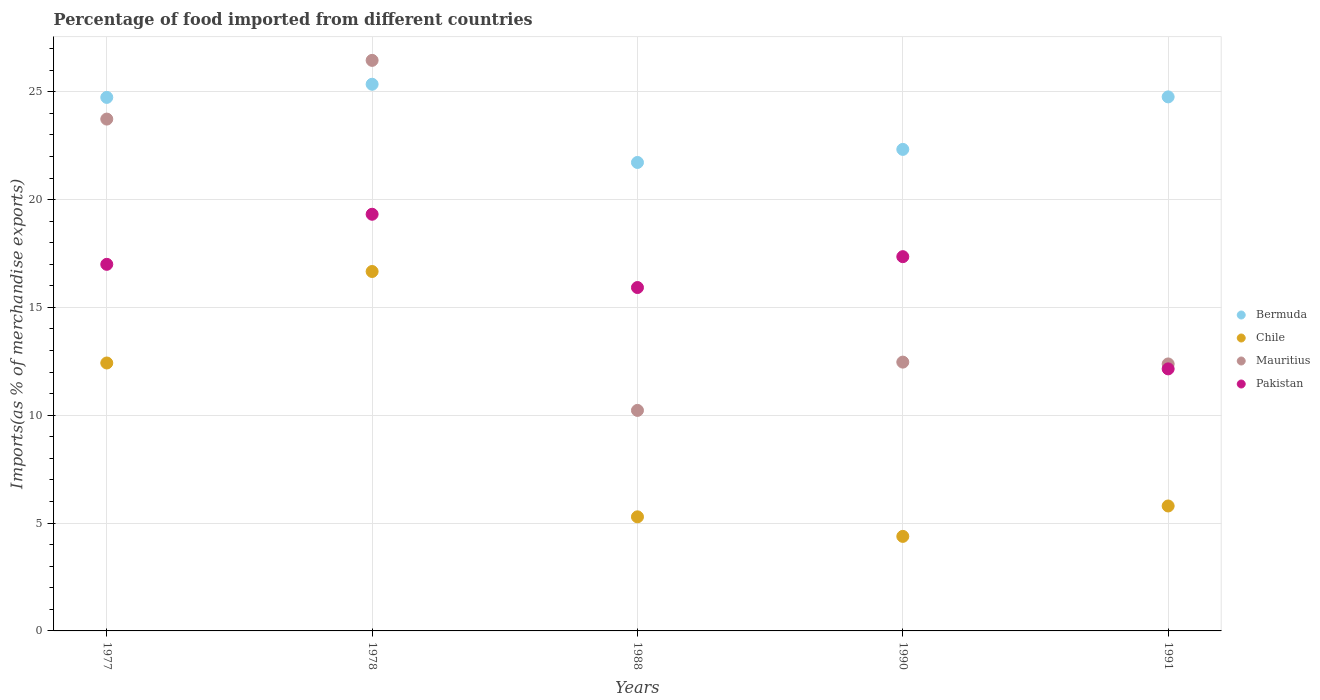Is the number of dotlines equal to the number of legend labels?
Make the answer very short. Yes. What is the percentage of imports to different countries in Mauritius in 1991?
Offer a very short reply. 12.38. Across all years, what is the maximum percentage of imports to different countries in Chile?
Provide a succinct answer. 16.67. Across all years, what is the minimum percentage of imports to different countries in Pakistan?
Your response must be concise. 12.15. In which year was the percentage of imports to different countries in Bermuda maximum?
Offer a terse response. 1978. What is the total percentage of imports to different countries in Chile in the graph?
Give a very brief answer. 44.55. What is the difference between the percentage of imports to different countries in Bermuda in 1978 and that in 1990?
Keep it short and to the point. 3.02. What is the difference between the percentage of imports to different countries in Pakistan in 1988 and the percentage of imports to different countries in Chile in 1977?
Make the answer very short. 3.5. What is the average percentage of imports to different countries in Chile per year?
Your answer should be compact. 8.91. In the year 1990, what is the difference between the percentage of imports to different countries in Bermuda and percentage of imports to different countries in Chile?
Provide a short and direct response. 17.94. In how many years, is the percentage of imports to different countries in Bermuda greater than 11 %?
Provide a short and direct response. 5. What is the ratio of the percentage of imports to different countries in Bermuda in 1978 to that in 1988?
Ensure brevity in your answer.  1.17. What is the difference between the highest and the second highest percentage of imports to different countries in Chile?
Your answer should be very brief. 4.24. What is the difference between the highest and the lowest percentage of imports to different countries in Bermuda?
Your answer should be compact. 3.63. In how many years, is the percentage of imports to different countries in Bermuda greater than the average percentage of imports to different countries in Bermuda taken over all years?
Keep it short and to the point. 3. Is the percentage of imports to different countries in Bermuda strictly less than the percentage of imports to different countries in Chile over the years?
Offer a very short reply. No. How many dotlines are there?
Provide a succinct answer. 4. How many years are there in the graph?
Your answer should be very brief. 5. Are the values on the major ticks of Y-axis written in scientific E-notation?
Keep it short and to the point. No. Does the graph contain any zero values?
Provide a succinct answer. No. How many legend labels are there?
Your answer should be very brief. 4. What is the title of the graph?
Make the answer very short. Percentage of food imported from different countries. What is the label or title of the Y-axis?
Ensure brevity in your answer.  Imports(as % of merchandise exports). What is the Imports(as % of merchandise exports) in Bermuda in 1977?
Provide a succinct answer. 24.74. What is the Imports(as % of merchandise exports) in Chile in 1977?
Provide a short and direct response. 12.42. What is the Imports(as % of merchandise exports) of Mauritius in 1977?
Provide a succinct answer. 23.73. What is the Imports(as % of merchandise exports) of Pakistan in 1977?
Your answer should be very brief. 17. What is the Imports(as % of merchandise exports) of Bermuda in 1978?
Ensure brevity in your answer.  25.35. What is the Imports(as % of merchandise exports) in Chile in 1978?
Provide a short and direct response. 16.67. What is the Imports(as % of merchandise exports) of Mauritius in 1978?
Provide a short and direct response. 26.45. What is the Imports(as % of merchandise exports) of Pakistan in 1978?
Your answer should be compact. 19.32. What is the Imports(as % of merchandise exports) of Bermuda in 1988?
Your response must be concise. 21.72. What is the Imports(as % of merchandise exports) in Chile in 1988?
Your answer should be very brief. 5.29. What is the Imports(as % of merchandise exports) in Mauritius in 1988?
Ensure brevity in your answer.  10.22. What is the Imports(as % of merchandise exports) in Pakistan in 1988?
Your response must be concise. 15.92. What is the Imports(as % of merchandise exports) in Bermuda in 1990?
Keep it short and to the point. 22.33. What is the Imports(as % of merchandise exports) in Chile in 1990?
Your response must be concise. 4.38. What is the Imports(as % of merchandise exports) of Mauritius in 1990?
Your response must be concise. 12.46. What is the Imports(as % of merchandise exports) of Pakistan in 1990?
Offer a very short reply. 17.35. What is the Imports(as % of merchandise exports) in Bermuda in 1991?
Your answer should be very brief. 24.76. What is the Imports(as % of merchandise exports) in Chile in 1991?
Ensure brevity in your answer.  5.79. What is the Imports(as % of merchandise exports) in Mauritius in 1991?
Make the answer very short. 12.38. What is the Imports(as % of merchandise exports) in Pakistan in 1991?
Your response must be concise. 12.15. Across all years, what is the maximum Imports(as % of merchandise exports) of Bermuda?
Offer a very short reply. 25.35. Across all years, what is the maximum Imports(as % of merchandise exports) in Chile?
Your response must be concise. 16.67. Across all years, what is the maximum Imports(as % of merchandise exports) of Mauritius?
Your answer should be compact. 26.45. Across all years, what is the maximum Imports(as % of merchandise exports) of Pakistan?
Make the answer very short. 19.32. Across all years, what is the minimum Imports(as % of merchandise exports) of Bermuda?
Ensure brevity in your answer.  21.72. Across all years, what is the minimum Imports(as % of merchandise exports) in Chile?
Provide a short and direct response. 4.38. Across all years, what is the minimum Imports(as % of merchandise exports) in Mauritius?
Your answer should be very brief. 10.22. Across all years, what is the minimum Imports(as % of merchandise exports) in Pakistan?
Keep it short and to the point. 12.15. What is the total Imports(as % of merchandise exports) in Bermuda in the graph?
Offer a terse response. 118.89. What is the total Imports(as % of merchandise exports) in Chile in the graph?
Keep it short and to the point. 44.55. What is the total Imports(as % of merchandise exports) of Mauritius in the graph?
Your answer should be compact. 85.25. What is the total Imports(as % of merchandise exports) of Pakistan in the graph?
Ensure brevity in your answer.  81.74. What is the difference between the Imports(as % of merchandise exports) of Bermuda in 1977 and that in 1978?
Provide a succinct answer. -0.61. What is the difference between the Imports(as % of merchandise exports) of Chile in 1977 and that in 1978?
Provide a succinct answer. -4.24. What is the difference between the Imports(as % of merchandise exports) of Mauritius in 1977 and that in 1978?
Offer a terse response. -2.72. What is the difference between the Imports(as % of merchandise exports) in Pakistan in 1977 and that in 1978?
Your answer should be very brief. -2.32. What is the difference between the Imports(as % of merchandise exports) in Bermuda in 1977 and that in 1988?
Provide a succinct answer. 3.02. What is the difference between the Imports(as % of merchandise exports) in Chile in 1977 and that in 1988?
Your response must be concise. 7.13. What is the difference between the Imports(as % of merchandise exports) of Mauritius in 1977 and that in 1988?
Offer a very short reply. 13.51. What is the difference between the Imports(as % of merchandise exports) in Pakistan in 1977 and that in 1988?
Provide a succinct answer. 1.08. What is the difference between the Imports(as % of merchandise exports) in Bermuda in 1977 and that in 1990?
Give a very brief answer. 2.41. What is the difference between the Imports(as % of merchandise exports) of Chile in 1977 and that in 1990?
Keep it short and to the point. 8.04. What is the difference between the Imports(as % of merchandise exports) in Mauritius in 1977 and that in 1990?
Give a very brief answer. 11.27. What is the difference between the Imports(as % of merchandise exports) in Pakistan in 1977 and that in 1990?
Ensure brevity in your answer.  -0.36. What is the difference between the Imports(as % of merchandise exports) in Bermuda in 1977 and that in 1991?
Your answer should be very brief. -0.02. What is the difference between the Imports(as % of merchandise exports) of Chile in 1977 and that in 1991?
Your response must be concise. 6.63. What is the difference between the Imports(as % of merchandise exports) of Mauritius in 1977 and that in 1991?
Offer a very short reply. 11.35. What is the difference between the Imports(as % of merchandise exports) of Pakistan in 1977 and that in 1991?
Ensure brevity in your answer.  4.85. What is the difference between the Imports(as % of merchandise exports) in Bermuda in 1978 and that in 1988?
Ensure brevity in your answer.  3.63. What is the difference between the Imports(as % of merchandise exports) in Chile in 1978 and that in 1988?
Keep it short and to the point. 11.38. What is the difference between the Imports(as % of merchandise exports) of Mauritius in 1978 and that in 1988?
Offer a terse response. 16.23. What is the difference between the Imports(as % of merchandise exports) of Pakistan in 1978 and that in 1988?
Keep it short and to the point. 3.4. What is the difference between the Imports(as % of merchandise exports) in Bermuda in 1978 and that in 1990?
Your response must be concise. 3.02. What is the difference between the Imports(as % of merchandise exports) of Chile in 1978 and that in 1990?
Offer a very short reply. 12.28. What is the difference between the Imports(as % of merchandise exports) of Mauritius in 1978 and that in 1990?
Your answer should be compact. 13.99. What is the difference between the Imports(as % of merchandise exports) in Pakistan in 1978 and that in 1990?
Give a very brief answer. 1.97. What is the difference between the Imports(as % of merchandise exports) of Bermuda in 1978 and that in 1991?
Your answer should be very brief. 0.59. What is the difference between the Imports(as % of merchandise exports) in Chile in 1978 and that in 1991?
Provide a short and direct response. 10.87. What is the difference between the Imports(as % of merchandise exports) of Mauritius in 1978 and that in 1991?
Give a very brief answer. 14.08. What is the difference between the Imports(as % of merchandise exports) of Pakistan in 1978 and that in 1991?
Offer a very short reply. 7.17. What is the difference between the Imports(as % of merchandise exports) of Bermuda in 1988 and that in 1990?
Provide a short and direct response. -0.61. What is the difference between the Imports(as % of merchandise exports) in Chile in 1988 and that in 1990?
Keep it short and to the point. 0.91. What is the difference between the Imports(as % of merchandise exports) in Mauritius in 1988 and that in 1990?
Your answer should be compact. -2.24. What is the difference between the Imports(as % of merchandise exports) in Pakistan in 1988 and that in 1990?
Offer a very short reply. -1.43. What is the difference between the Imports(as % of merchandise exports) in Bermuda in 1988 and that in 1991?
Your response must be concise. -3.04. What is the difference between the Imports(as % of merchandise exports) of Chile in 1988 and that in 1991?
Ensure brevity in your answer.  -0.5. What is the difference between the Imports(as % of merchandise exports) in Mauritius in 1988 and that in 1991?
Make the answer very short. -2.15. What is the difference between the Imports(as % of merchandise exports) of Pakistan in 1988 and that in 1991?
Keep it short and to the point. 3.77. What is the difference between the Imports(as % of merchandise exports) in Bermuda in 1990 and that in 1991?
Your answer should be very brief. -2.43. What is the difference between the Imports(as % of merchandise exports) of Chile in 1990 and that in 1991?
Your response must be concise. -1.41. What is the difference between the Imports(as % of merchandise exports) in Mauritius in 1990 and that in 1991?
Ensure brevity in your answer.  0.08. What is the difference between the Imports(as % of merchandise exports) of Pakistan in 1990 and that in 1991?
Keep it short and to the point. 5.2. What is the difference between the Imports(as % of merchandise exports) of Bermuda in 1977 and the Imports(as % of merchandise exports) of Chile in 1978?
Give a very brief answer. 8.07. What is the difference between the Imports(as % of merchandise exports) of Bermuda in 1977 and the Imports(as % of merchandise exports) of Mauritius in 1978?
Provide a succinct answer. -1.72. What is the difference between the Imports(as % of merchandise exports) in Bermuda in 1977 and the Imports(as % of merchandise exports) in Pakistan in 1978?
Keep it short and to the point. 5.42. What is the difference between the Imports(as % of merchandise exports) in Chile in 1977 and the Imports(as % of merchandise exports) in Mauritius in 1978?
Your answer should be compact. -14.03. What is the difference between the Imports(as % of merchandise exports) in Chile in 1977 and the Imports(as % of merchandise exports) in Pakistan in 1978?
Make the answer very short. -6.9. What is the difference between the Imports(as % of merchandise exports) in Mauritius in 1977 and the Imports(as % of merchandise exports) in Pakistan in 1978?
Your response must be concise. 4.41. What is the difference between the Imports(as % of merchandise exports) in Bermuda in 1977 and the Imports(as % of merchandise exports) in Chile in 1988?
Make the answer very short. 19.45. What is the difference between the Imports(as % of merchandise exports) of Bermuda in 1977 and the Imports(as % of merchandise exports) of Mauritius in 1988?
Make the answer very short. 14.51. What is the difference between the Imports(as % of merchandise exports) of Bermuda in 1977 and the Imports(as % of merchandise exports) of Pakistan in 1988?
Your answer should be compact. 8.82. What is the difference between the Imports(as % of merchandise exports) of Chile in 1977 and the Imports(as % of merchandise exports) of Mauritius in 1988?
Provide a succinct answer. 2.2. What is the difference between the Imports(as % of merchandise exports) of Chile in 1977 and the Imports(as % of merchandise exports) of Pakistan in 1988?
Your response must be concise. -3.5. What is the difference between the Imports(as % of merchandise exports) in Mauritius in 1977 and the Imports(as % of merchandise exports) in Pakistan in 1988?
Keep it short and to the point. 7.81. What is the difference between the Imports(as % of merchandise exports) of Bermuda in 1977 and the Imports(as % of merchandise exports) of Chile in 1990?
Your answer should be very brief. 20.35. What is the difference between the Imports(as % of merchandise exports) of Bermuda in 1977 and the Imports(as % of merchandise exports) of Mauritius in 1990?
Keep it short and to the point. 12.27. What is the difference between the Imports(as % of merchandise exports) of Bermuda in 1977 and the Imports(as % of merchandise exports) of Pakistan in 1990?
Offer a very short reply. 7.38. What is the difference between the Imports(as % of merchandise exports) of Chile in 1977 and the Imports(as % of merchandise exports) of Mauritius in 1990?
Offer a very short reply. -0.04. What is the difference between the Imports(as % of merchandise exports) of Chile in 1977 and the Imports(as % of merchandise exports) of Pakistan in 1990?
Ensure brevity in your answer.  -4.93. What is the difference between the Imports(as % of merchandise exports) in Mauritius in 1977 and the Imports(as % of merchandise exports) in Pakistan in 1990?
Keep it short and to the point. 6.38. What is the difference between the Imports(as % of merchandise exports) in Bermuda in 1977 and the Imports(as % of merchandise exports) in Chile in 1991?
Ensure brevity in your answer.  18.94. What is the difference between the Imports(as % of merchandise exports) of Bermuda in 1977 and the Imports(as % of merchandise exports) of Mauritius in 1991?
Offer a very short reply. 12.36. What is the difference between the Imports(as % of merchandise exports) of Bermuda in 1977 and the Imports(as % of merchandise exports) of Pakistan in 1991?
Your answer should be very brief. 12.59. What is the difference between the Imports(as % of merchandise exports) in Chile in 1977 and the Imports(as % of merchandise exports) in Mauritius in 1991?
Give a very brief answer. 0.04. What is the difference between the Imports(as % of merchandise exports) in Chile in 1977 and the Imports(as % of merchandise exports) in Pakistan in 1991?
Your answer should be compact. 0.27. What is the difference between the Imports(as % of merchandise exports) of Mauritius in 1977 and the Imports(as % of merchandise exports) of Pakistan in 1991?
Your response must be concise. 11.58. What is the difference between the Imports(as % of merchandise exports) in Bermuda in 1978 and the Imports(as % of merchandise exports) in Chile in 1988?
Offer a very short reply. 20.06. What is the difference between the Imports(as % of merchandise exports) in Bermuda in 1978 and the Imports(as % of merchandise exports) in Mauritius in 1988?
Your answer should be very brief. 15.12. What is the difference between the Imports(as % of merchandise exports) in Bermuda in 1978 and the Imports(as % of merchandise exports) in Pakistan in 1988?
Offer a terse response. 9.43. What is the difference between the Imports(as % of merchandise exports) of Chile in 1978 and the Imports(as % of merchandise exports) of Mauritius in 1988?
Your response must be concise. 6.44. What is the difference between the Imports(as % of merchandise exports) of Chile in 1978 and the Imports(as % of merchandise exports) of Pakistan in 1988?
Your answer should be very brief. 0.74. What is the difference between the Imports(as % of merchandise exports) in Mauritius in 1978 and the Imports(as % of merchandise exports) in Pakistan in 1988?
Offer a very short reply. 10.53. What is the difference between the Imports(as % of merchandise exports) in Bermuda in 1978 and the Imports(as % of merchandise exports) in Chile in 1990?
Your answer should be compact. 20.96. What is the difference between the Imports(as % of merchandise exports) in Bermuda in 1978 and the Imports(as % of merchandise exports) in Mauritius in 1990?
Give a very brief answer. 12.88. What is the difference between the Imports(as % of merchandise exports) of Bermuda in 1978 and the Imports(as % of merchandise exports) of Pakistan in 1990?
Provide a short and direct response. 7.99. What is the difference between the Imports(as % of merchandise exports) in Chile in 1978 and the Imports(as % of merchandise exports) in Mauritius in 1990?
Your answer should be compact. 4.2. What is the difference between the Imports(as % of merchandise exports) in Chile in 1978 and the Imports(as % of merchandise exports) in Pakistan in 1990?
Provide a short and direct response. -0.69. What is the difference between the Imports(as % of merchandise exports) in Mauritius in 1978 and the Imports(as % of merchandise exports) in Pakistan in 1990?
Your response must be concise. 9.1. What is the difference between the Imports(as % of merchandise exports) of Bermuda in 1978 and the Imports(as % of merchandise exports) of Chile in 1991?
Your answer should be very brief. 19.55. What is the difference between the Imports(as % of merchandise exports) of Bermuda in 1978 and the Imports(as % of merchandise exports) of Mauritius in 1991?
Offer a terse response. 12.97. What is the difference between the Imports(as % of merchandise exports) in Bermuda in 1978 and the Imports(as % of merchandise exports) in Pakistan in 1991?
Give a very brief answer. 13.2. What is the difference between the Imports(as % of merchandise exports) of Chile in 1978 and the Imports(as % of merchandise exports) of Mauritius in 1991?
Your response must be concise. 4.29. What is the difference between the Imports(as % of merchandise exports) in Chile in 1978 and the Imports(as % of merchandise exports) in Pakistan in 1991?
Provide a succinct answer. 4.52. What is the difference between the Imports(as % of merchandise exports) in Mauritius in 1978 and the Imports(as % of merchandise exports) in Pakistan in 1991?
Offer a very short reply. 14.3. What is the difference between the Imports(as % of merchandise exports) in Bermuda in 1988 and the Imports(as % of merchandise exports) in Chile in 1990?
Make the answer very short. 17.34. What is the difference between the Imports(as % of merchandise exports) of Bermuda in 1988 and the Imports(as % of merchandise exports) of Mauritius in 1990?
Provide a succinct answer. 9.26. What is the difference between the Imports(as % of merchandise exports) of Bermuda in 1988 and the Imports(as % of merchandise exports) of Pakistan in 1990?
Your answer should be very brief. 4.37. What is the difference between the Imports(as % of merchandise exports) in Chile in 1988 and the Imports(as % of merchandise exports) in Mauritius in 1990?
Your answer should be compact. -7.17. What is the difference between the Imports(as % of merchandise exports) in Chile in 1988 and the Imports(as % of merchandise exports) in Pakistan in 1990?
Offer a terse response. -12.06. What is the difference between the Imports(as % of merchandise exports) in Mauritius in 1988 and the Imports(as % of merchandise exports) in Pakistan in 1990?
Ensure brevity in your answer.  -7.13. What is the difference between the Imports(as % of merchandise exports) in Bermuda in 1988 and the Imports(as % of merchandise exports) in Chile in 1991?
Give a very brief answer. 15.93. What is the difference between the Imports(as % of merchandise exports) in Bermuda in 1988 and the Imports(as % of merchandise exports) in Mauritius in 1991?
Ensure brevity in your answer.  9.34. What is the difference between the Imports(as % of merchandise exports) in Bermuda in 1988 and the Imports(as % of merchandise exports) in Pakistan in 1991?
Ensure brevity in your answer.  9.57. What is the difference between the Imports(as % of merchandise exports) in Chile in 1988 and the Imports(as % of merchandise exports) in Mauritius in 1991?
Ensure brevity in your answer.  -7.09. What is the difference between the Imports(as % of merchandise exports) of Chile in 1988 and the Imports(as % of merchandise exports) of Pakistan in 1991?
Provide a short and direct response. -6.86. What is the difference between the Imports(as % of merchandise exports) of Mauritius in 1988 and the Imports(as % of merchandise exports) of Pakistan in 1991?
Offer a terse response. -1.93. What is the difference between the Imports(as % of merchandise exports) in Bermuda in 1990 and the Imports(as % of merchandise exports) in Chile in 1991?
Provide a short and direct response. 16.53. What is the difference between the Imports(as % of merchandise exports) of Bermuda in 1990 and the Imports(as % of merchandise exports) of Mauritius in 1991?
Provide a short and direct response. 9.95. What is the difference between the Imports(as % of merchandise exports) in Bermuda in 1990 and the Imports(as % of merchandise exports) in Pakistan in 1991?
Ensure brevity in your answer.  10.18. What is the difference between the Imports(as % of merchandise exports) of Chile in 1990 and the Imports(as % of merchandise exports) of Mauritius in 1991?
Provide a short and direct response. -8. What is the difference between the Imports(as % of merchandise exports) of Chile in 1990 and the Imports(as % of merchandise exports) of Pakistan in 1991?
Offer a terse response. -7.77. What is the difference between the Imports(as % of merchandise exports) of Mauritius in 1990 and the Imports(as % of merchandise exports) of Pakistan in 1991?
Your response must be concise. 0.31. What is the average Imports(as % of merchandise exports) in Bermuda per year?
Your answer should be compact. 23.78. What is the average Imports(as % of merchandise exports) of Chile per year?
Offer a terse response. 8.91. What is the average Imports(as % of merchandise exports) of Mauritius per year?
Make the answer very short. 17.05. What is the average Imports(as % of merchandise exports) of Pakistan per year?
Offer a very short reply. 16.35. In the year 1977, what is the difference between the Imports(as % of merchandise exports) of Bermuda and Imports(as % of merchandise exports) of Chile?
Provide a succinct answer. 12.31. In the year 1977, what is the difference between the Imports(as % of merchandise exports) of Bermuda and Imports(as % of merchandise exports) of Pakistan?
Keep it short and to the point. 7.74. In the year 1977, what is the difference between the Imports(as % of merchandise exports) of Chile and Imports(as % of merchandise exports) of Mauritius?
Provide a succinct answer. -11.31. In the year 1977, what is the difference between the Imports(as % of merchandise exports) in Chile and Imports(as % of merchandise exports) in Pakistan?
Keep it short and to the point. -4.57. In the year 1977, what is the difference between the Imports(as % of merchandise exports) in Mauritius and Imports(as % of merchandise exports) in Pakistan?
Offer a very short reply. 6.73. In the year 1978, what is the difference between the Imports(as % of merchandise exports) of Bermuda and Imports(as % of merchandise exports) of Chile?
Your answer should be compact. 8.68. In the year 1978, what is the difference between the Imports(as % of merchandise exports) in Bermuda and Imports(as % of merchandise exports) in Mauritius?
Make the answer very short. -1.11. In the year 1978, what is the difference between the Imports(as % of merchandise exports) in Bermuda and Imports(as % of merchandise exports) in Pakistan?
Your response must be concise. 6.03. In the year 1978, what is the difference between the Imports(as % of merchandise exports) in Chile and Imports(as % of merchandise exports) in Mauritius?
Your response must be concise. -9.79. In the year 1978, what is the difference between the Imports(as % of merchandise exports) of Chile and Imports(as % of merchandise exports) of Pakistan?
Ensure brevity in your answer.  -2.65. In the year 1978, what is the difference between the Imports(as % of merchandise exports) of Mauritius and Imports(as % of merchandise exports) of Pakistan?
Provide a short and direct response. 7.13. In the year 1988, what is the difference between the Imports(as % of merchandise exports) in Bermuda and Imports(as % of merchandise exports) in Chile?
Your response must be concise. 16.43. In the year 1988, what is the difference between the Imports(as % of merchandise exports) of Bermuda and Imports(as % of merchandise exports) of Mauritius?
Your response must be concise. 11.5. In the year 1988, what is the difference between the Imports(as % of merchandise exports) of Bermuda and Imports(as % of merchandise exports) of Pakistan?
Offer a very short reply. 5.8. In the year 1988, what is the difference between the Imports(as % of merchandise exports) in Chile and Imports(as % of merchandise exports) in Mauritius?
Offer a very short reply. -4.93. In the year 1988, what is the difference between the Imports(as % of merchandise exports) of Chile and Imports(as % of merchandise exports) of Pakistan?
Give a very brief answer. -10.63. In the year 1988, what is the difference between the Imports(as % of merchandise exports) in Mauritius and Imports(as % of merchandise exports) in Pakistan?
Keep it short and to the point. -5.7. In the year 1990, what is the difference between the Imports(as % of merchandise exports) in Bermuda and Imports(as % of merchandise exports) in Chile?
Make the answer very short. 17.94. In the year 1990, what is the difference between the Imports(as % of merchandise exports) in Bermuda and Imports(as % of merchandise exports) in Mauritius?
Ensure brevity in your answer.  9.86. In the year 1990, what is the difference between the Imports(as % of merchandise exports) of Bermuda and Imports(as % of merchandise exports) of Pakistan?
Your answer should be compact. 4.97. In the year 1990, what is the difference between the Imports(as % of merchandise exports) in Chile and Imports(as % of merchandise exports) in Mauritius?
Provide a succinct answer. -8.08. In the year 1990, what is the difference between the Imports(as % of merchandise exports) of Chile and Imports(as % of merchandise exports) of Pakistan?
Your response must be concise. -12.97. In the year 1990, what is the difference between the Imports(as % of merchandise exports) in Mauritius and Imports(as % of merchandise exports) in Pakistan?
Keep it short and to the point. -4.89. In the year 1991, what is the difference between the Imports(as % of merchandise exports) in Bermuda and Imports(as % of merchandise exports) in Chile?
Provide a short and direct response. 18.97. In the year 1991, what is the difference between the Imports(as % of merchandise exports) of Bermuda and Imports(as % of merchandise exports) of Mauritius?
Ensure brevity in your answer.  12.38. In the year 1991, what is the difference between the Imports(as % of merchandise exports) in Bermuda and Imports(as % of merchandise exports) in Pakistan?
Offer a very short reply. 12.61. In the year 1991, what is the difference between the Imports(as % of merchandise exports) of Chile and Imports(as % of merchandise exports) of Mauritius?
Your answer should be compact. -6.59. In the year 1991, what is the difference between the Imports(as % of merchandise exports) in Chile and Imports(as % of merchandise exports) in Pakistan?
Provide a short and direct response. -6.36. In the year 1991, what is the difference between the Imports(as % of merchandise exports) of Mauritius and Imports(as % of merchandise exports) of Pakistan?
Your response must be concise. 0.23. What is the ratio of the Imports(as % of merchandise exports) in Bermuda in 1977 to that in 1978?
Make the answer very short. 0.98. What is the ratio of the Imports(as % of merchandise exports) of Chile in 1977 to that in 1978?
Your answer should be compact. 0.75. What is the ratio of the Imports(as % of merchandise exports) in Mauritius in 1977 to that in 1978?
Provide a succinct answer. 0.9. What is the ratio of the Imports(as % of merchandise exports) of Pakistan in 1977 to that in 1978?
Provide a short and direct response. 0.88. What is the ratio of the Imports(as % of merchandise exports) of Bermuda in 1977 to that in 1988?
Offer a terse response. 1.14. What is the ratio of the Imports(as % of merchandise exports) of Chile in 1977 to that in 1988?
Offer a terse response. 2.35. What is the ratio of the Imports(as % of merchandise exports) in Mauritius in 1977 to that in 1988?
Your response must be concise. 2.32. What is the ratio of the Imports(as % of merchandise exports) of Pakistan in 1977 to that in 1988?
Make the answer very short. 1.07. What is the ratio of the Imports(as % of merchandise exports) in Bermuda in 1977 to that in 1990?
Your answer should be very brief. 1.11. What is the ratio of the Imports(as % of merchandise exports) in Chile in 1977 to that in 1990?
Ensure brevity in your answer.  2.83. What is the ratio of the Imports(as % of merchandise exports) of Mauritius in 1977 to that in 1990?
Keep it short and to the point. 1.9. What is the ratio of the Imports(as % of merchandise exports) in Pakistan in 1977 to that in 1990?
Keep it short and to the point. 0.98. What is the ratio of the Imports(as % of merchandise exports) in Chile in 1977 to that in 1991?
Offer a terse response. 2.14. What is the ratio of the Imports(as % of merchandise exports) of Mauritius in 1977 to that in 1991?
Offer a very short reply. 1.92. What is the ratio of the Imports(as % of merchandise exports) of Pakistan in 1977 to that in 1991?
Offer a terse response. 1.4. What is the ratio of the Imports(as % of merchandise exports) of Bermuda in 1978 to that in 1988?
Give a very brief answer. 1.17. What is the ratio of the Imports(as % of merchandise exports) of Chile in 1978 to that in 1988?
Give a very brief answer. 3.15. What is the ratio of the Imports(as % of merchandise exports) of Mauritius in 1978 to that in 1988?
Make the answer very short. 2.59. What is the ratio of the Imports(as % of merchandise exports) of Pakistan in 1978 to that in 1988?
Your answer should be very brief. 1.21. What is the ratio of the Imports(as % of merchandise exports) of Bermuda in 1978 to that in 1990?
Your answer should be very brief. 1.14. What is the ratio of the Imports(as % of merchandise exports) in Chile in 1978 to that in 1990?
Provide a succinct answer. 3.8. What is the ratio of the Imports(as % of merchandise exports) in Mauritius in 1978 to that in 1990?
Provide a short and direct response. 2.12. What is the ratio of the Imports(as % of merchandise exports) of Pakistan in 1978 to that in 1990?
Give a very brief answer. 1.11. What is the ratio of the Imports(as % of merchandise exports) of Bermuda in 1978 to that in 1991?
Offer a very short reply. 1.02. What is the ratio of the Imports(as % of merchandise exports) in Chile in 1978 to that in 1991?
Make the answer very short. 2.88. What is the ratio of the Imports(as % of merchandise exports) in Mauritius in 1978 to that in 1991?
Your answer should be compact. 2.14. What is the ratio of the Imports(as % of merchandise exports) in Pakistan in 1978 to that in 1991?
Your answer should be compact. 1.59. What is the ratio of the Imports(as % of merchandise exports) in Bermuda in 1988 to that in 1990?
Ensure brevity in your answer.  0.97. What is the ratio of the Imports(as % of merchandise exports) of Chile in 1988 to that in 1990?
Your answer should be compact. 1.21. What is the ratio of the Imports(as % of merchandise exports) in Mauritius in 1988 to that in 1990?
Provide a short and direct response. 0.82. What is the ratio of the Imports(as % of merchandise exports) of Pakistan in 1988 to that in 1990?
Your answer should be very brief. 0.92. What is the ratio of the Imports(as % of merchandise exports) of Bermuda in 1988 to that in 1991?
Your answer should be very brief. 0.88. What is the ratio of the Imports(as % of merchandise exports) of Chile in 1988 to that in 1991?
Offer a very short reply. 0.91. What is the ratio of the Imports(as % of merchandise exports) in Mauritius in 1988 to that in 1991?
Give a very brief answer. 0.83. What is the ratio of the Imports(as % of merchandise exports) in Pakistan in 1988 to that in 1991?
Provide a short and direct response. 1.31. What is the ratio of the Imports(as % of merchandise exports) of Bermuda in 1990 to that in 1991?
Keep it short and to the point. 0.9. What is the ratio of the Imports(as % of merchandise exports) in Chile in 1990 to that in 1991?
Provide a short and direct response. 0.76. What is the ratio of the Imports(as % of merchandise exports) of Mauritius in 1990 to that in 1991?
Make the answer very short. 1.01. What is the ratio of the Imports(as % of merchandise exports) of Pakistan in 1990 to that in 1991?
Provide a short and direct response. 1.43. What is the difference between the highest and the second highest Imports(as % of merchandise exports) in Bermuda?
Keep it short and to the point. 0.59. What is the difference between the highest and the second highest Imports(as % of merchandise exports) in Chile?
Make the answer very short. 4.24. What is the difference between the highest and the second highest Imports(as % of merchandise exports) in Mauritius?
Offer a very short reply. 2.72. What is the difference between the highest and the second highest Imports(as % of merchandise exports) in Pakistan?
Keep it short and to the point. 1.97. What is the difference between the highest and the lowest Imports(as % of merchandise exports) in Bermuda?
Provide a short and direct response. 3.63. What is the difference between the highest and the lowest Imports(as % of merchandise exports) of Chile?
Keep it short and to the point. 12.28. What is the difference between the highest and the lowest Imports(as % of merchandise exports) of Mauritius?
Ensure brevity in your answer.  16.23. What is the difference between the highest and the lowest Imports(as % of merchandise exports) of Pakistan?
Your answer should be very brief. 7.17. 